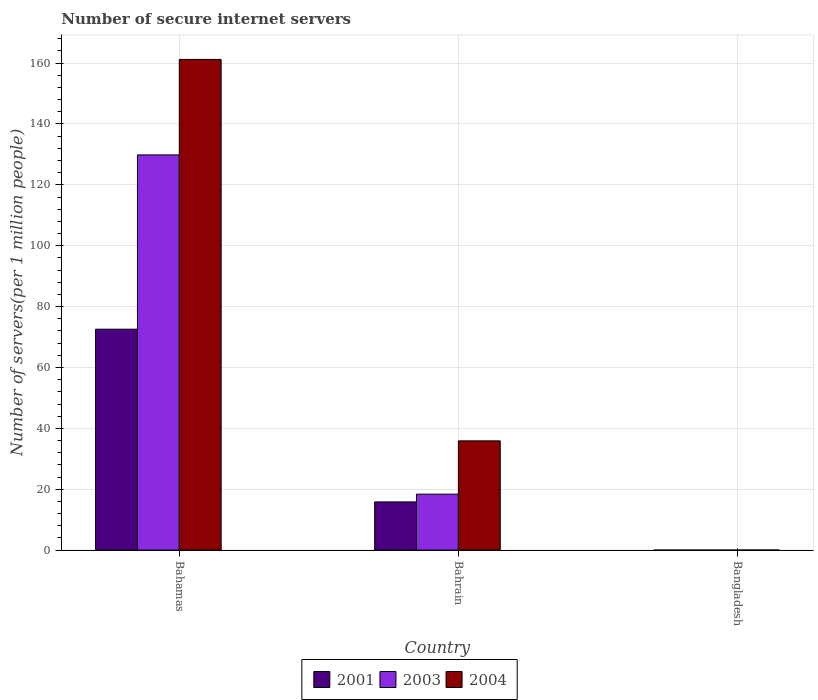How many groups of bars are there?
Make the answer very short. 3. Are the number of bars per tick equal to the number of legend labels?
Provide a short and direct response. Yes. Are the number of bars on each tick of the X-axis equal?
Your answer should be very brief. Yes. How many bars are there on the 1st tick from the left?
Your response must be concise. 3. What is the label of the 2nd group of bars from the left?
Your answer should be very brief. Bahrain. What is the number of secure internet servers in 2001 in Bahrain?
Keep it short and to the point. 15.83. Across all countries, what is the maximum number of secure internet servers in 2003?
Provide a short and direct response. 129.85. Across all countries, what is the minimum number of secure internet servers in 2004?
Offer a terse response. 0.02. In which country was the number of secure internet servers in 2001 maximum?
Give a very brief answer. Bahamas. What is the total number of secure internet servers in 2001 in the graph?
Your response must be concise. 88.41. What is the difference between the number of secure internet servers in 2001 in Bahrain and that in Bangladesh?
Your answer should be compact. 15.82. What is the difference between the number of secure internet servers in 2001 in Bangladesh and the number of secure internet servers in 2004 in Bahrain?
Your answer should be very brief. -35.88. What is the average number of secure internet servers in 2003 per country?
Keep it short and to the point. 49.41. What is the difference between the number of secure internet servers of/in 2004 and number of secure internet servers of/in 2001 in Bahamas?
Provide a succinct answer. 88.65. What is the ratio of the number of secure internet servers in 2003 in Bahamas to that in Bangladesh?
Give a very brief answer. 1.80e+04. Is the difference between the number of secure internet servers in 2004 in Bahamas and Bangladesh greater than the difference between the number of secure internet servers in 2001 in Bahamas and Bangladesh?
Provide a succinct answer. Yes. What is the difference between the highest and the second highest number of secure internet servers in 2004?
Provide a short and direct response. -161.2. What is the difference between the highest and the lowest number of secure internet servers in 2004?
Offer a very short reply. 161.2. How many bars are there?
Your response must be concise. 9. Are all the bars in the graph horizontal?
Keep it short and to the point. No. Are the values on the major ticks of Y-axis written in scientific E-notation?
Your answer should be compact. No. Does the graph contain any zero values?
Provide a succinct answer. No. What is the title of the graph?
Keep it short and to the point. Number of secure internet servers. Does "1981" appear as one of the legend labels in the graph?
Your response must be concise. No. What is the label or title of the X-axis?
Keep it short and to the point. Country. What is the label or title of the Y-axis?
Your answer should be compact. Number of servers(per 1 million people). What is the Number of servers(per 1 million people) in 2001 in Bahamas?
Your answer should be very brief. 72.57. What is the Number of servers(per 1 million people) in 2003 in Bahamas?
Keep it short and to the point. 129.85. What is the Number of servers(per 1 million people) of 2004 in Bahamas?
Provide a succinct answer. 161.22. What is the Number of servers(per 1 million people) of 2001 in Bahrain?
Give a very brief answer. 15.83. What is the Number of servers(per 1 million people) in 2003 in Bahrain?
Give a very brief answer. 18.38. What is the Number of servers(per 1 million people) of 2004 in Bahrain?
Give a very brief answer. 35.89. What is the Number of servers(per 1 million people) of 2001 in Bangladesh?
Ensure brevity in your answer.  0.01. What is the Number of servers(per 1 million people) of 2003 in Bangladesh?
Your response must be concise. 0.01. What is the Number of servers(per 1 million people) in 2004 in Bangladesh?
Your response must be concise. 0.02. Across all countries, what is the maximum Number of servers(per 1 million people) in 2001?
Give a very brief answer. 72.57. Across all countries, what is the maximum Number of servers(per 1 million people) in 2003?
Provide a succinct answer. 129.85. Across all countries, what is the maximum Number of servers(per 1 million people) of 2004?
Give a very brief answer. 161.22. Across all countries, what is the minimum Number of servers(per 1 million people) of 2001?
Give a very brief answer. 0.01. Across all countries, what is the minimum Number of servers(per 1 million people) in 2003?
Your answer should be very brief. 0.01. Across all countries, what is the minimum Number of servers(per 1 million people) of 2004?
Ensure brevity in your answer.  0.02. What is the total Number of servers(per 1 million people) in 2001 in the graph?
Make the answer very short. 88.41. What is the total Number of servers(per 1 million people) in 2003 in the graph?
Give a very brief answer. 148.24. What is the total Number of servers(per 1 million people) of 2004 in the graph?
Provide a succinct answer. 197.13. What is the difference between the Number of servers(per 1 million people) in 2001 in Bahamas and that in Bahrain?
Offer a very short reply. 56.74. What is the difference between the Number of servers(per 1 million people) of 2003 in Bahamas and that in Bahrain?
Give a very brief answer. 111.46. What is the difference between the Number of servers(per 1 million people) in 2004 in Bahamas and that in Bahrain?
Provide a short and direct response. 125.33. What is the difference between the Number of servers(per 1 million people) of 2001 in Bahamas and that in Bangladesh?
Make the answer very short. 72.57. What is the difference between the Number of servers(per 1 million people) in 2003 in Bahamas and that in Bangladesh?
Your answer should be compact. 129.84. What is the difference between the Number of servers(per 1 million people) in 2004 in Bahamas and that in Bangladesh?
Provide a succinct answer. 161.2. What is the difference between the Number of servers(per 1 million people) of 2001 in Bahrain and that in Bangladesh?
Your answer should be very brief. 15.82. What is the difference between the Number of servers(per 1 million people) of 2003 in Bahrain and that in Bangladesh?
Ensure brevity in your answer.  18.38. What is the difference between the Number of servers(per 1 million people) of 2004 in Bahrain and that in Bangladesh?
Make the answer very short. 35.87. What is the difference between the Number of servers(per 1 million people) in 2001 in Bahamas and the Number of servers(per 1 million people) in 2003 in Bahrain?
Make the answer very short. 54.19. What is the difference between the Number of servers(per 1 million people) of 2001 in Bahamas and the Number of servers(per 1 million people) of 2004 in Bahrain?
Give a very brief answer. 36.68. What is the difference between the Number of servers(per 1 million people) in 2003 in Bahamas and the Number of servers(per 1 million people) in 2004 in Bahrain?
Make the answer very short. 93.96. What is the difference between the Number of servers(per 1 million people) in 2001 in Bahamas and the Number of servers(per 1 million people) in 2003 in Bangladesh?
Make the answer very short. 72.57. What is the difference between the Number of servers(per 1 million people) of 2001 in Bahamas and the Number of servers(per 1 million people) of 2004 in Bangladesh?
Your answer should be compact. 72.55. What is the difference between the Number of servers(per 1 million people) of 2003 in Bahamas and the Number of servers(per 1 million people) of 2004 in Bangladesh?
Ensure brevity in your answer.  129.83. What is the difference between the Number of servers(per 1 million people) in 2001 in Bahrain and the Number of servers(per 1 million people) in 2003 in Bangladesh?
Your response must be concise. 15.82. What is the difference between the Number of servers(per 1 million people) of 2001 in Bahrain and the Number of servers(per 1 million people) of 2004 in Bangladesh?
Provide a short and direct response. 15.81. What is the difference between the Number of servers(per 1 million people) of 2003 in Bahrain and the Number of servers(per 1 million people) of 2004 in Bangladesh?
Offer a terse response. 18.36. What is the average Number of servers(per 1 million people) of 2001 per country?
Ensure brevity in your answer.  29.47. What is the average Number of servers(per 1 million people) in 2003 per country?
Your answer should be very brief. 49.41. What is the average Number of servers(per 1 million people) of 2004 per country?
Your answer should be very brief. 65.71. What is the difference between the Number of servers(per 1 million people) of 2001 and Number of servers(per 1 million people) of 2003 in Bahamas?
Keep it short and to the point. -57.27. What is the difference between the Number of servers(per 1 million people) in 2001 and Number of servers(per 1 million people) in 2004 in Bahamas?
Provide a succinct answer. -88.65. What is the difference between the Number of servers(per 1 million people) in 2003 and Number of servers(per 1 million people) in 2004 in Bahamas?
Make the answer very short. -31.37. What is the difference between the Number of servers(per 1 million people) of 2001 and Number of servers(per 1 million people) of 2003 in Bahrain?
Your answer should be compact. -2.55. What is the difference between the Number of servers(per 1 million people) in 2001 and Number of servers(per 1 million people) in 2004 in Bahrain?
Ensure brevity in your answer.  -20.06. What is the difference between the Number of servers(per 1 million people) of 2003 and Number of servers(per 1 million people) of 2004 in Bahrain?
Provide a short and direct response. -17.51. What is the difference between the Number of servers(per 1 million people) of 2001 and Number of servers(per 1 million people) of 2003 in Bangladesh?
Your response must be concise. 0. What is the difference between the Number of servers(per 1 million people) of 2001 and Number of servers(per 1 million people) of 2004 in Bangladesh?
Ensure brevity in your answer.  -0.01. What is the difference between the Number of servers(per 1 million people) in 2003 and Number of servers(per 1 million people) in 2004 in Bangladesh?
Provide a succinct answer. -0.01. What is the ratio of the Number of servers(per 1 million people) of 2001 in Bahamas to that in Bahrain?
Give a very brief answer. 4.58. What is the ratio of the Number of servers(per 1 million people) of 2003 in Bahamas to that in Bahrain?
Give a very brief answer. 7.06. What is the ratio of the Number of servers(per 1 million people) of 2004 in Bahamas to that in Bahrain?
Your response must be concise. 4.49. What is the ratio of the Number of servers(per 1 million people) of 2001 in Bahamas to that in Bangladesh?
Your response must be concise. 9708.69. What is the ratio of the Number of servers(per 1 million people) in 2003 in Bahamas to that in Bangladesh?
Offer a very short reply. 1.80e+04. What is the ratio of the Number of servers(per 1 million people) in 2004 in Bahamas to that in Bangladesh?
Your response must be concise. 7568.98. What is the ratio of the Number of servers(per 1 million people) of 2001 in Bahrain to that in Bangladesh?
Provide a short and direct response. 2117.64. What is the ratio of the Number of servers(per 1 million people) of 2003 in Bahrain to that in Bangladesh?
Provide a short and direct response. 2547.81. What is the ratio of the Number of servers(per 1 million people) of 2004 in Bahrain to that in Bangladesh?
Keep it short and to the point. 1685.04. What is the difference between the highest and the second highest Number of servers(per 1 million people) in 2001?
Keep it short and to the point. 56.74. What is the difference between the highest and the second highest Number of servers(per 1 million people) of 2003?
Provide a succinct answer. 111.46. What is the difference between the highest and the second highest Number of servers(per 1 million people) in 2004?
Your answer should be compact. 125.33. What is the difference between the highest and the lowest Number of servers(per 1 million people) in 2001?
Offer a very short reply. 72.57. What is the difference between the highest and the lowest Number of servers(per 1 million people) of 2003?
Make the answer very short. 129.84. What is the difference between the highest and the lowest Number of servers(per 1 million people) of 2004?
Your answer should be very brief. 161.2. 